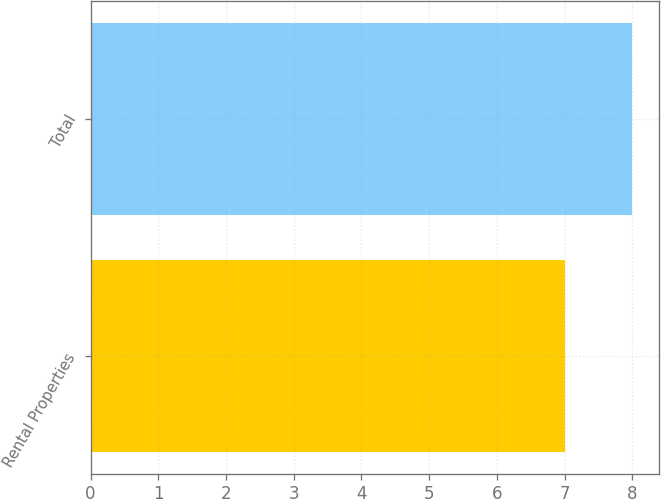<chart> <loc_0><loc_0><loc_500><loc_500><bar_chart><fcel>Rental Properties<fcel>Total<nl><fcel>7<fcel>8<nl></chart> 